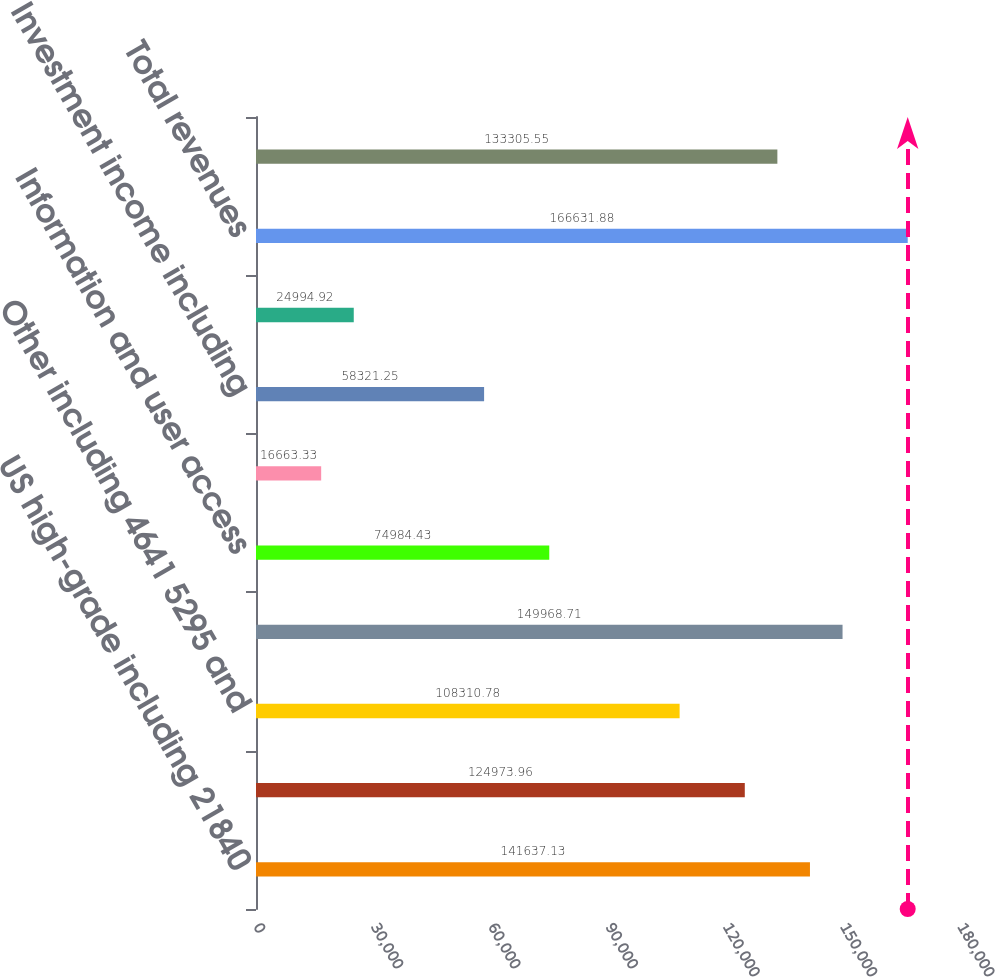Convert chart. <chart><loc_0><loc_0><loc_500><loc_500><bar_chart><fcel>US high-grade including 21840<fcel>European high-grade including<fcel>Other including 4641 5295 and<fcel>Total commissions<fcel>Information and user access<fcel>License fees<fcel>Investment income including<fcel>the years ended December 31<fcel>Total revenues<fcel>Employee compensation and<nl><fcel>141637<fcel>124974<fcel>108311<fcel>149969<fcel>74984.4<fcel>16663.3<fcel>58321.2<fcel>24994.9<fcel>166632<fcel>133306<nl></chart> 